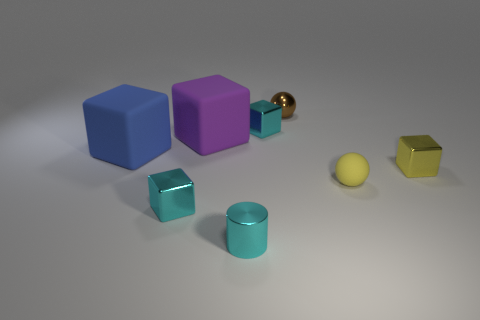Subtract all blue matte blocks. How many blocks are left? 4 Subtract all purple blocks. How many blocks are left? 4 Subtract 1 cubes. How many cubes are left? 4 Add 2 large gray cubes. How many objects exist? 10 Subtract all spheres. How many objects are left? 6 Subtract all small yellow things. Subtract all yellow metal cubes. How many objects are left? 5 Add 2 blue rubber blocks. How many blue rubber blocks are left? 3 Add 6 purple spheres. How many purple spheres exist? 6 Subtract 1 purple blocks. How many objects are left? 7 Subtract all blue cubes. Subtract all blue cylinders. How many cubes are left? 4 